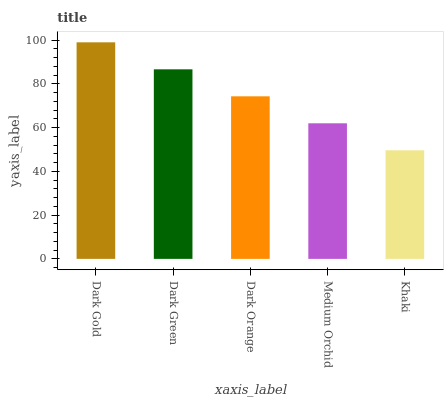Is Khaki the minimum?
Answer yes or no. Yes. Is Dark Gold the maximum?
Answer yes or no. Yes. Is Dark Green the minimum?
Answer yes or no. No. Is Dark Green the maximum?
Answer yes or no. No. Is Dark Gold greater than Dark Green?
Answer yes or no. Yes. Is Dark Green less than Dark Gold?
Answer yes or no. Yes. Is Dark Green greater than Dark Gold?
Answer yes or no. No. Is Dark Gold less than Dark Green?
Answer yes or no. No. Is Dark Orange the high median?
Answer yes or no. Yes. Is Dark Orange the low median?
Answer yes or no. Yes. Is Khaki the high median?
Answer yes or no. No. Is Dark Green the low median?
Answer yes or no. No. 